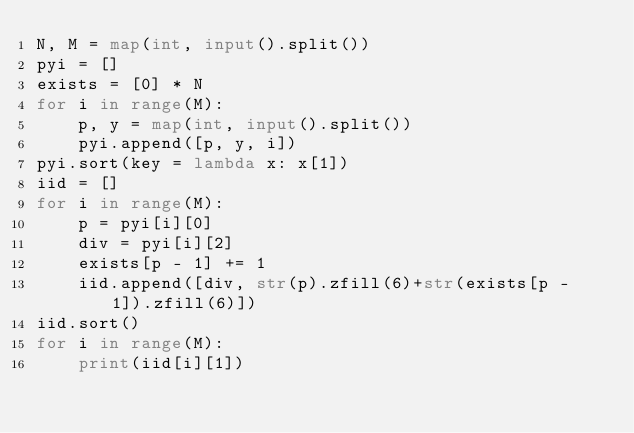<code> <loc_0><loc_0><loc_500><loc_500><_Python_>N, M = map(int, input().split())
pyi = []
exists = [0] * N
for i in range(M):
    p, y = map(int, input().split())
    pyi.append([p, y, i])
pyi.sort(key = lambda x: x[1])
iid = []
for i in range(M):
    p = pyi[i][0]
    div = pyi[i][2]
    exists[p - 1] += 1
    iid.append([div, str(p).zfill(6)+str(exists[p - 1]).zfill(6)])
iid.sort()
for i in range(M):
    print(iid[i][1])</code> 